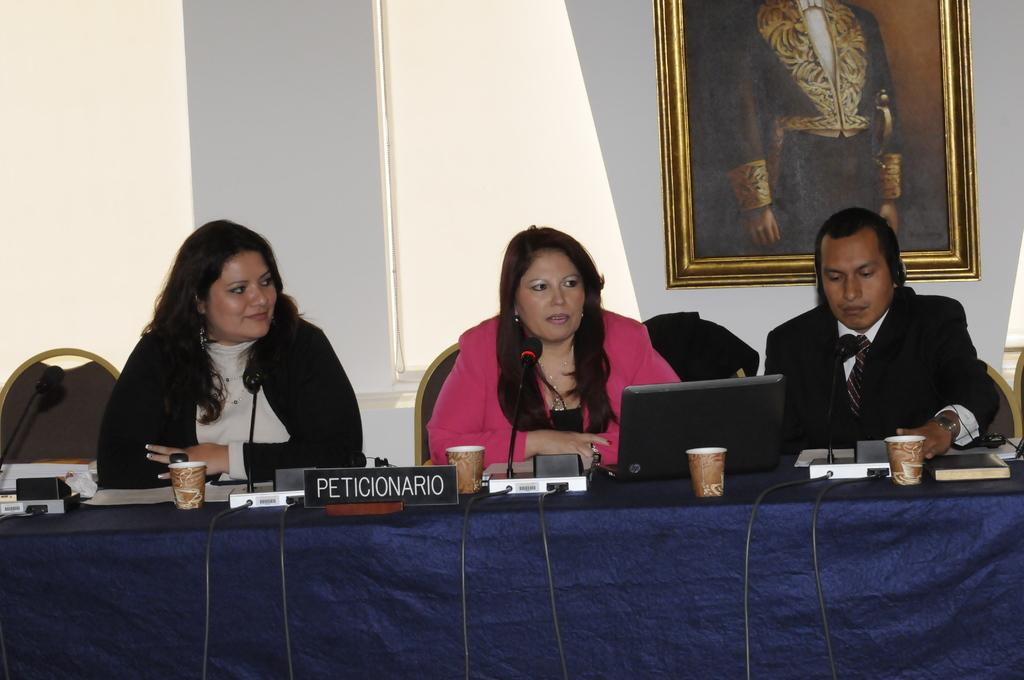What are the people in the image doing? The people in the image are sitting on chairs. What objects can be seen on the table in the image? There are glasses, a laptop, a mic with a stand, and a book on the table. Is there anything hanging on the wall in the background? Yes, there is a photo frame on the wall in the background. What type of ornament is hanging from the ceiling in the image? There is no ornament hanging from the ceiling in the image. What color are the beads on the mic stand in the image? There are no beads on the mic stand in the image; it is a mic with a stand. 